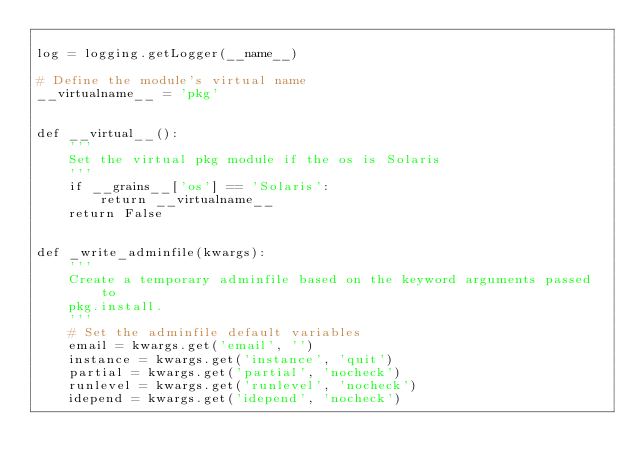Convert code to text. <code><loc_0><loc_0><loc_500><loc_500><_Python_>
log = logging.getLogger(__name__)

# Define the module's virtual name
__virtualname__ = 'pkg'


def __virtual__():
    '''
    Set the virtual pkg module if the os is Solaris
    '''
    if __grains__['os'] == 'Solaris':
        return __virtualname__
    return False


def _write_adminfile(kwargs):
    '''
    Create a temporary adminfile based on the keyword arguments passed to
    pkg.install.
    '''
    # Set the adminfile default variables
    email = kwargs.get('email', '')
    instance = kwargs.get('instance', 'quit')
    partial = kwargs.get('partial', 'nocheck')
    runlevel = kwargs.get('runlevel', 'nocheck')
    idepend = kwargs.get('idepend', 'nocheck')</code> 